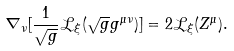<formula> <loc_0><loc_0><loc_500><loc_500>\nabla _ { \nu } [ \frac { 1 } { \sqrt { g } } \mathcal { L } _ { \xi } ( \sqrt { g } g ^ { \mu \nu } ) ] = 2 \mathcal { L } _ { \xi } ( Z ^ { \mu } ) .</formula> 